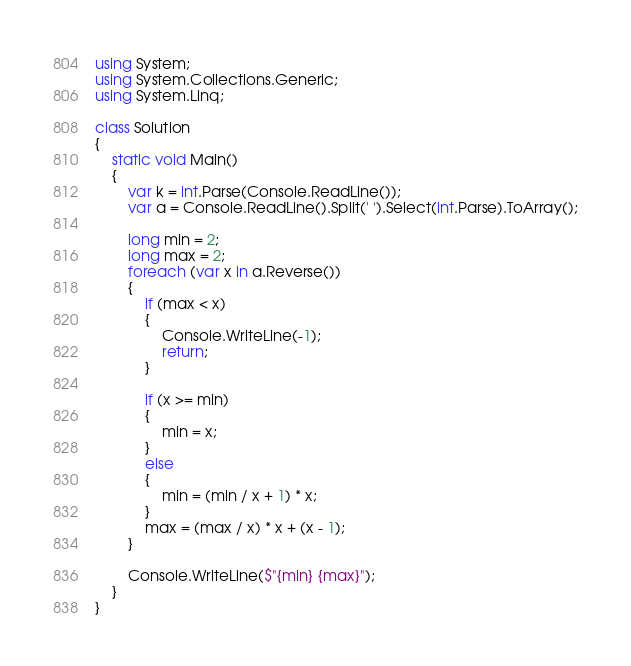<code> <loc_0><loc_0><loc_500><loc_500><_C#_>using System;
using System.Collections.Generic;
using System.Linq;

class Solution
{
    static void Main()
    {
        var k = int.Parse(Console.ReadLine());
        var a = Console.ReadLine().Split(' ').Select(int.Parse).ToArray();

        long min = 2;
        long max = 2;
        foreach (var x in a.Reverse())
        {
            if (max < x)
            {
                Console.WriteLine(-1);
                return;
            }

            if (x >= min)
            {
                min = x;
            }
            else
            {
                min = (min / x + 1) * x;
            }
            max = (max / x) * x + (x - 1);
        }

        Console.WriteLine($"{min} {max}");
    }
}</code> 